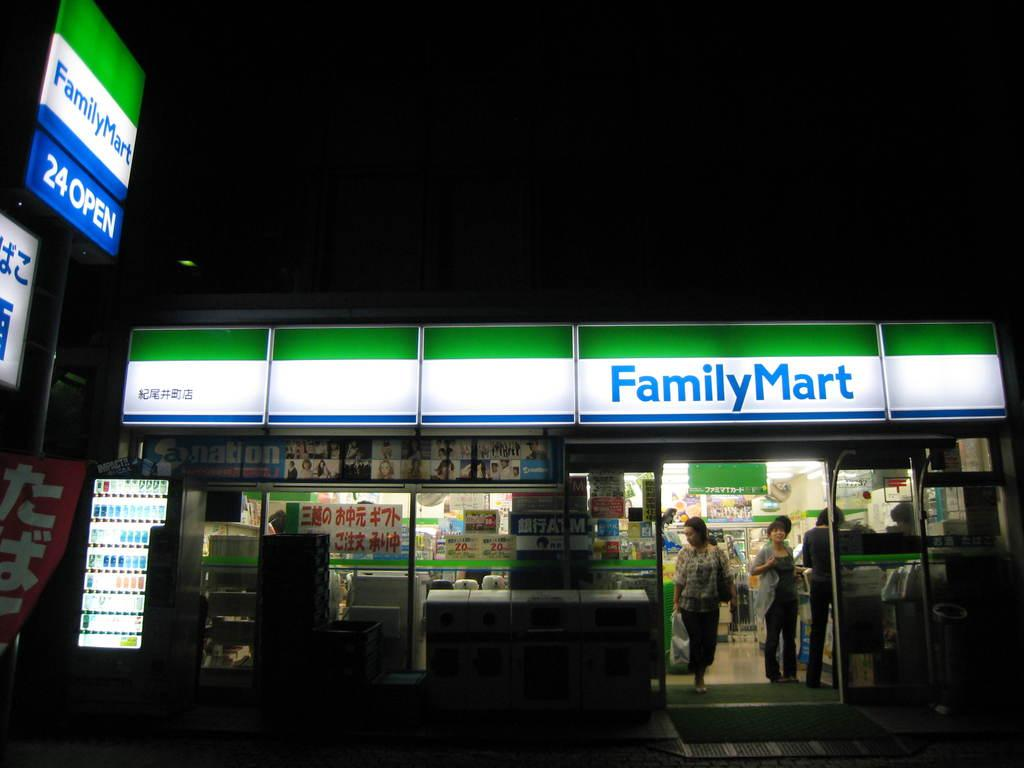<image>
Offer a succinct explanation of the picture presented. A night scene of a FamilyMart shows people in the doorway. 